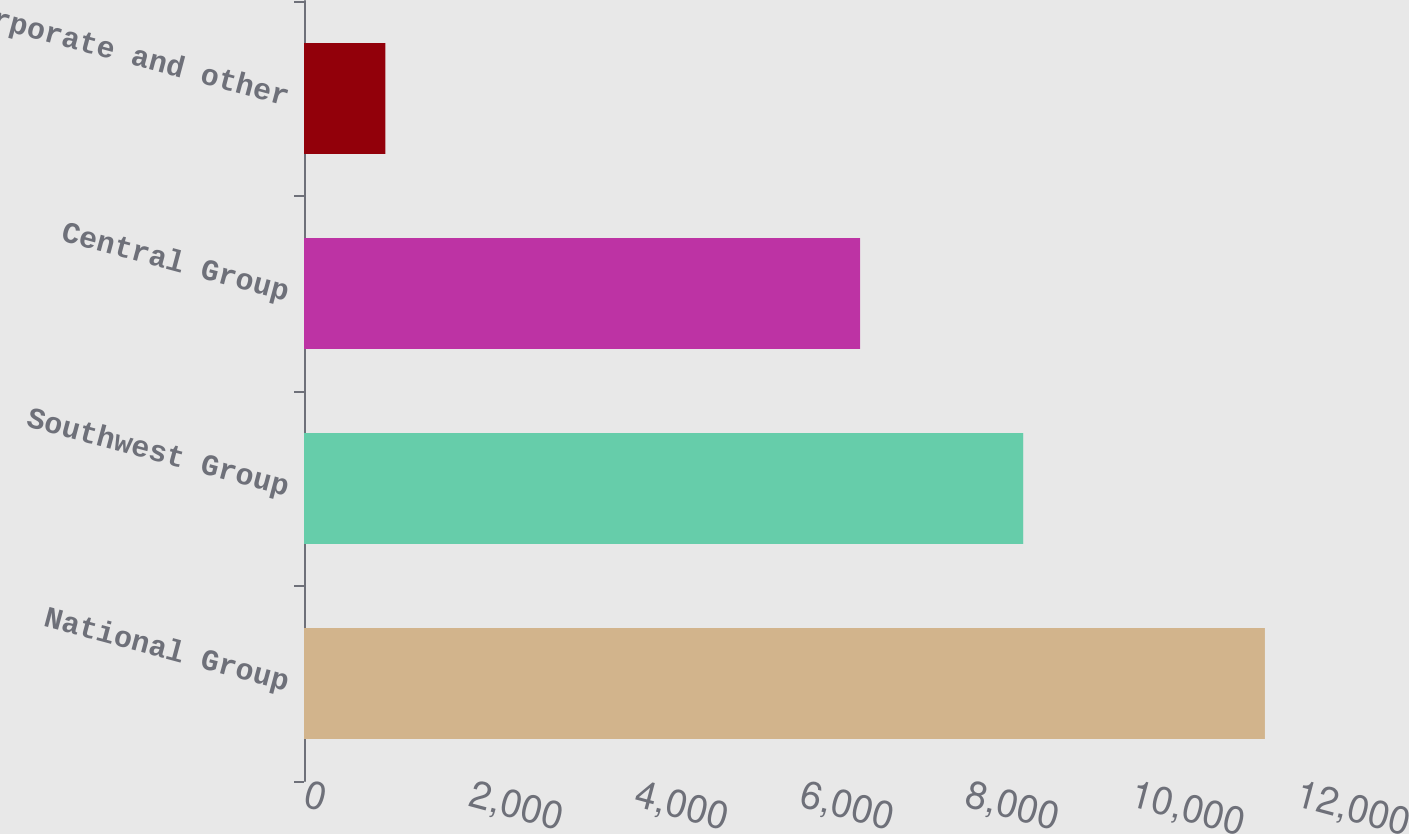Convert chart. <chart><loc_0><loc_0><loc_500><loc_500><bar_chart><fcel>National Group<fcel>Southwest Group<fcel>Central Group<fcel>Corporate and other<nl><fcel>11624<fcel>8700<fcel>6727<fcel>984<nl></chart> 